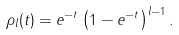Convert formula to latex. <formula><loc_0><loc_0><loc_500><loc_500>\rho _ { l } ( t ) = e ^ { - t } \left ( 1 - e ^ { - t } \right ) ^ { l - 1 } .</formula> 